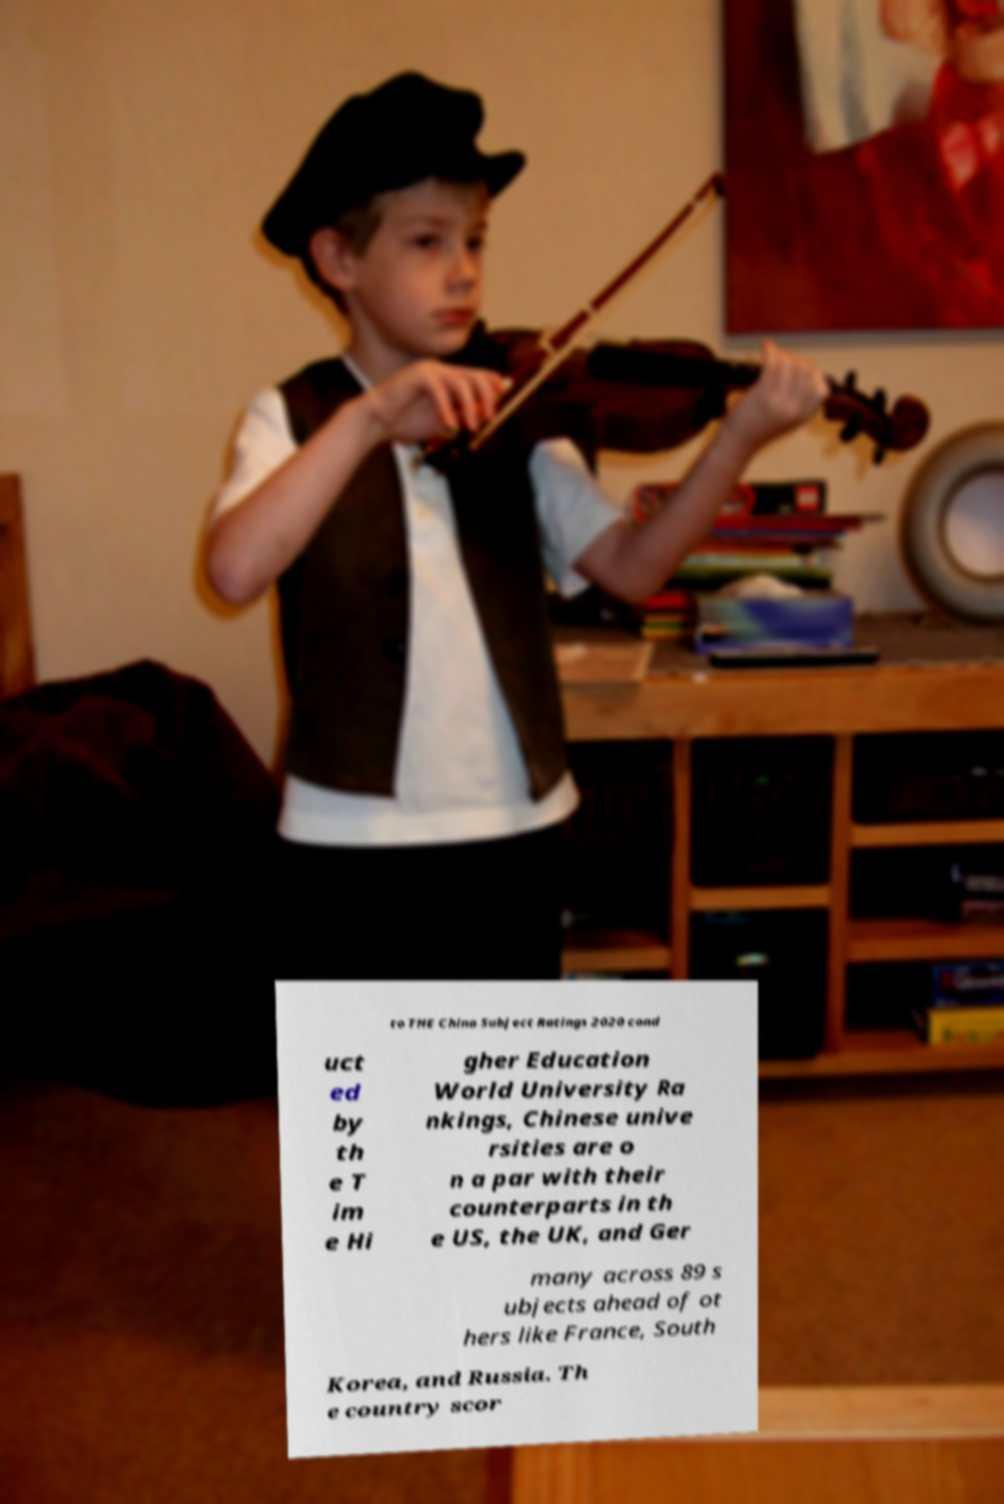Can you read and provide the text displayed in the image?This photo seems to have some interesting text. Can you extract and type it out for me? to THE China Subject Ratings 2020 cond uct ed by th e T im e Hi gher Education World University Ra nkings, Chinese unive rsities are o n a par with their counterparts in th e US, the UK, and Ger many across 89 s ubjects ahead of ot hers like France, South Korea, and Russia. Th e country scor 